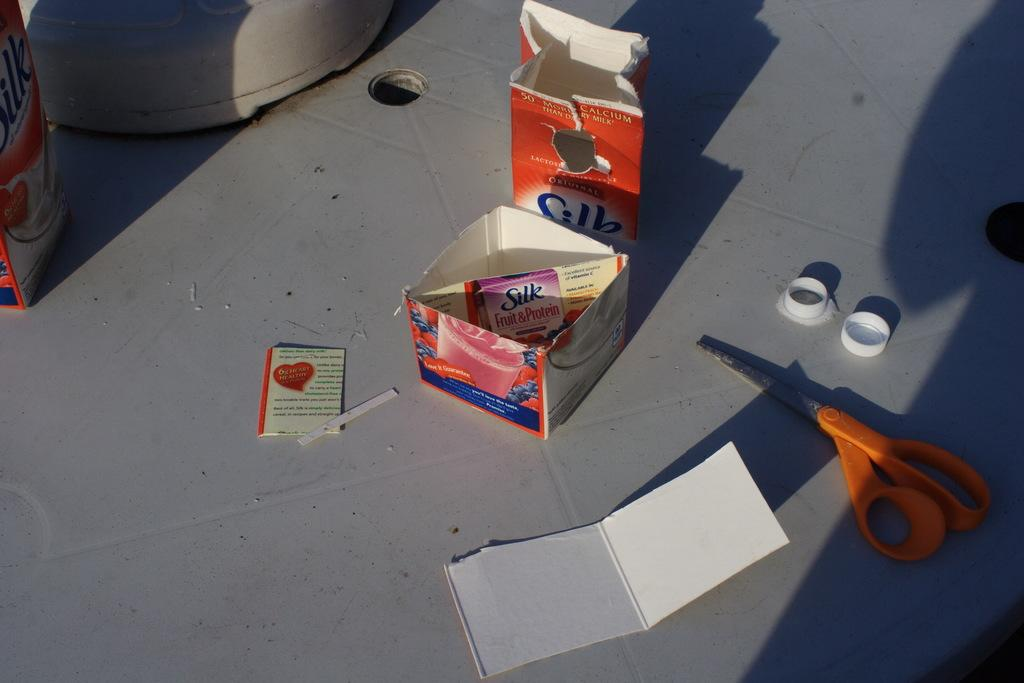<image>
Relay a brief, clear account of the picture shown. cut up empty carton of silk fruit & protein next to pair of scissors with orange handle 